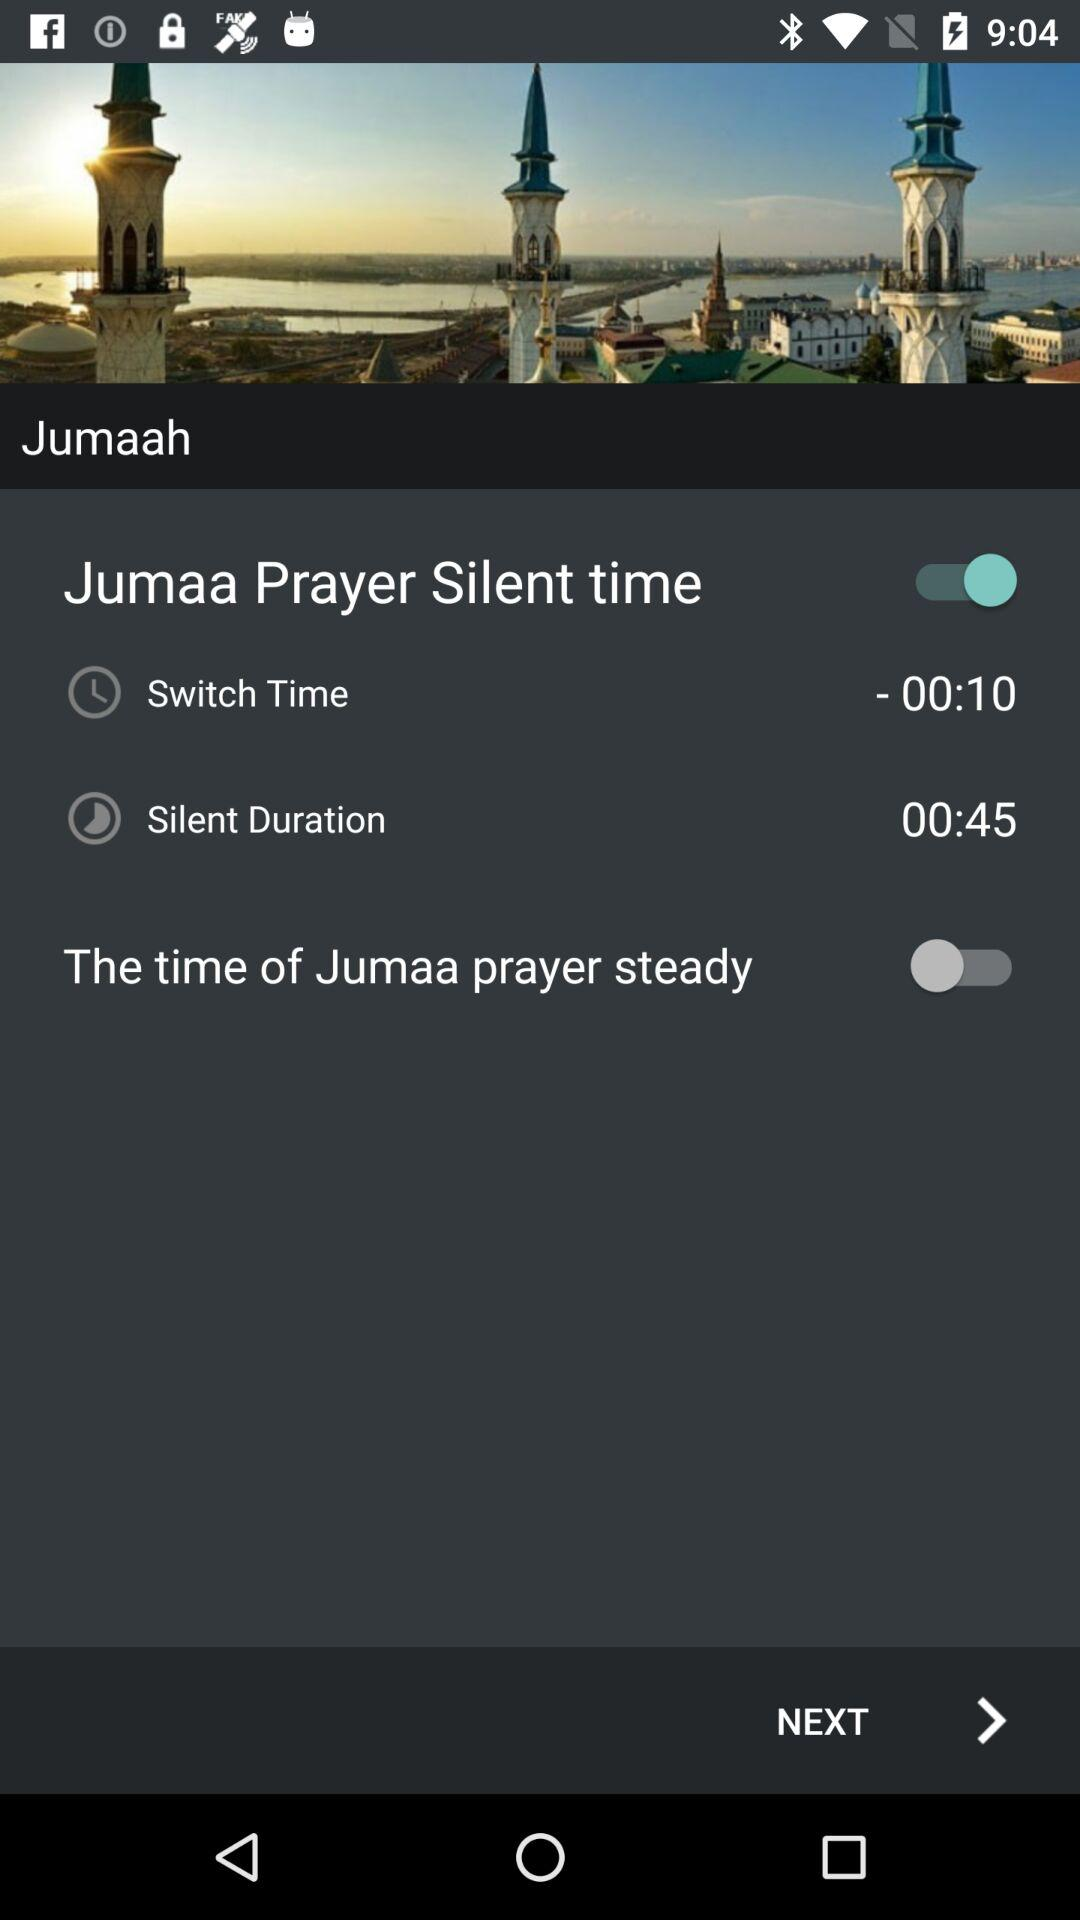What's the status of the Jumma Prayer Silent Time? The status of Jumma Prayer Silent Time is on. 